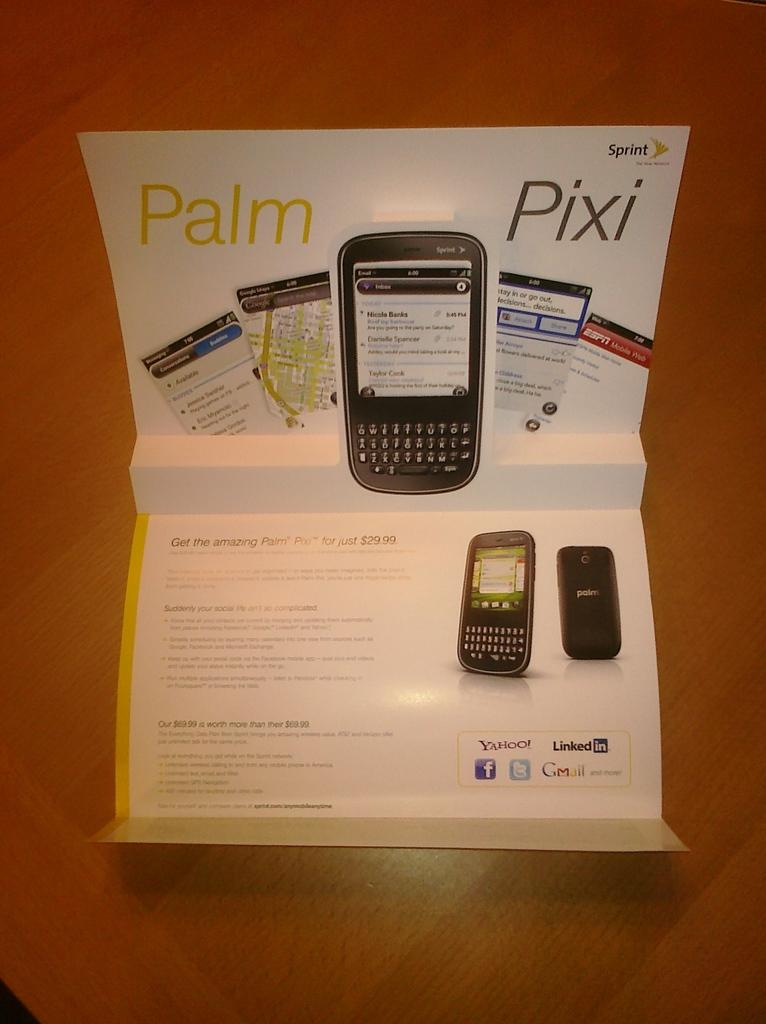Provide a one-sentence caption for the provided image. a booklet with the word pixi on it. 